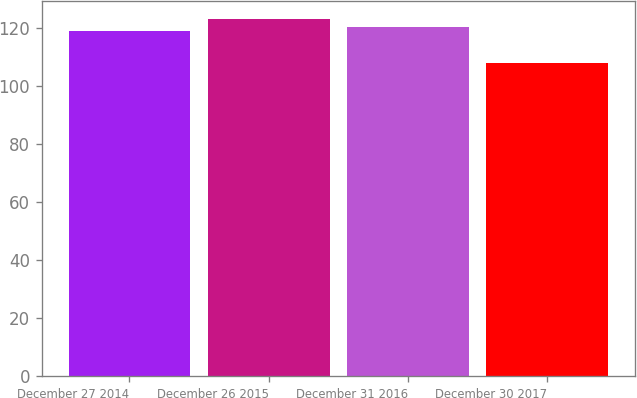Convert chart to OTSL. <chart><loc_0><loc_0><loc_500><loc_500><bar_chart><fcel>December 27 2014<fcel>December 26 2015<fcel>December 31 2016<fcel>December 30 2017<nl><fcel>119<fcel>123<fcel>120.5<fcel>108<nl></chart> 